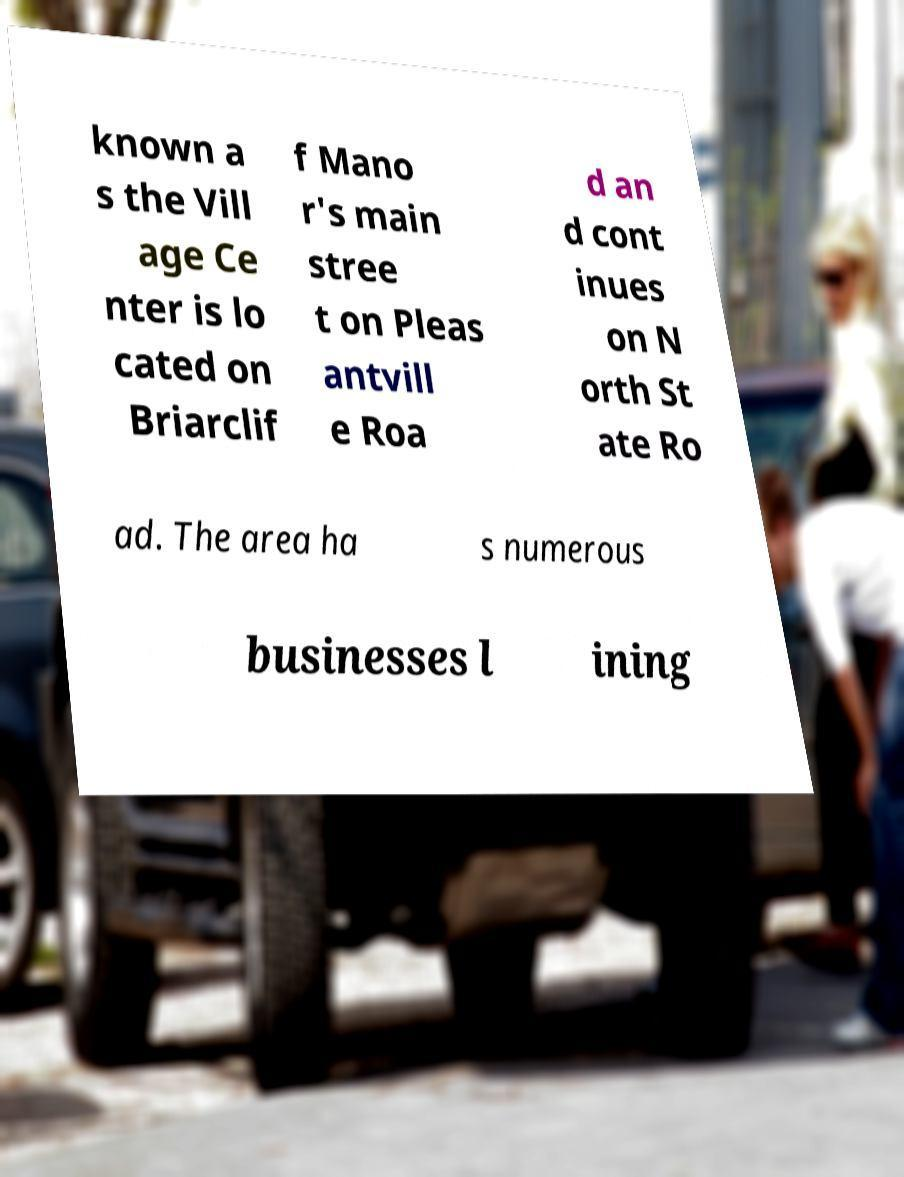There's text embedded in this image that I need extracted. Can you transcribe it verbatim? known a s the Vill age Ce nter is lo cated on Briarclif f Mano r's main stree t on Pleas antvill e Roa d an d cont inues on N orth St ate Ro ad. The area ha s numerous businesses l ining 